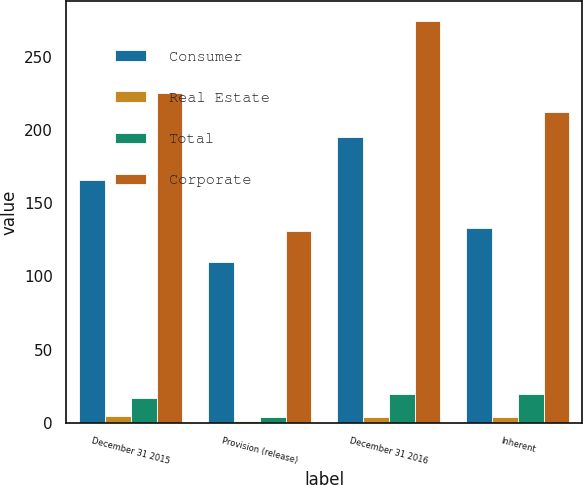<chart> <loc_0><loc_0><loc_500><loc_500><stacked_bar_chart><ecel><fcel>December 31 2015<fcel>Provision (release)<fcel>December 31 2016<fcel>Inherent<nl><fcel>Consumer<fcel>166<fcel>110<fcel>195<fcel>133<nl><fcel>Real Estate<fcel>5<fcel>1<fcel>4<fcel>4<nl><fcel>Total<fcel>17<fcel>4<fcel>20<fcel>20<nl><fcel>Corporate<fcel>225<fcel>131<fcel>274<fcel>212<nl></chart> 